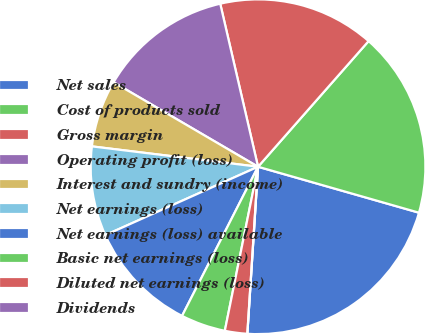<chart> <loc_0><loc_0><loc_500><loc_500><pie_chart><fcel>Net sales<fcel>Cost of products sold<fcel>Gross margin<fcel>Operating profit (loss)<fcel>Interest and sundry (income)<fcel>Net earnings (loss)<fcel>Net earnings (loss) available<fcel>Basic net earnings (loss)<fcel>Diluted net earnings (loss)<fcel>Dividends<nl><fcel>21.59%<fcel>17.94%<fcel>15.11%<fcel>12.95%<fcel>6.48%<fcel>8.64%<fcel>10.8%<fcel>4.32%<fcel>2.16%<fcel>0.0%<nl></chart> 